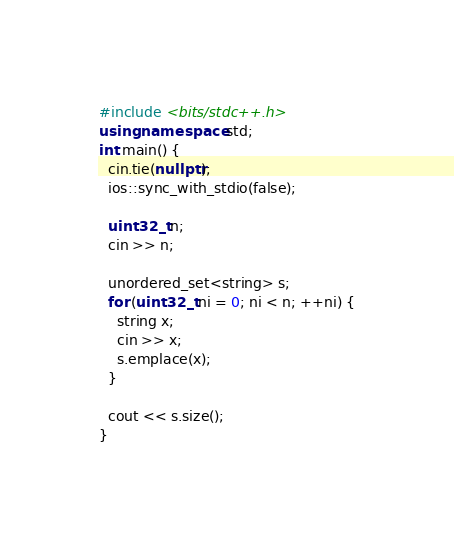<code> <loc_0><loc_0><loc_500><loc_500><_C++_>#include <bits/stdc++.h>
using namespace std;
int main() {
  cin.tie(nullptr);
  ios::sync_with_stdio(false);

  uint32_t n;
  cin >> n;

  unordered_set<string> s;
  for (uint32_t ni = 0; ni < n; ++ni) {
    string x;
    cin >> x;
    s.emplace(x);
  }

  cout << s.size();
}</code> 